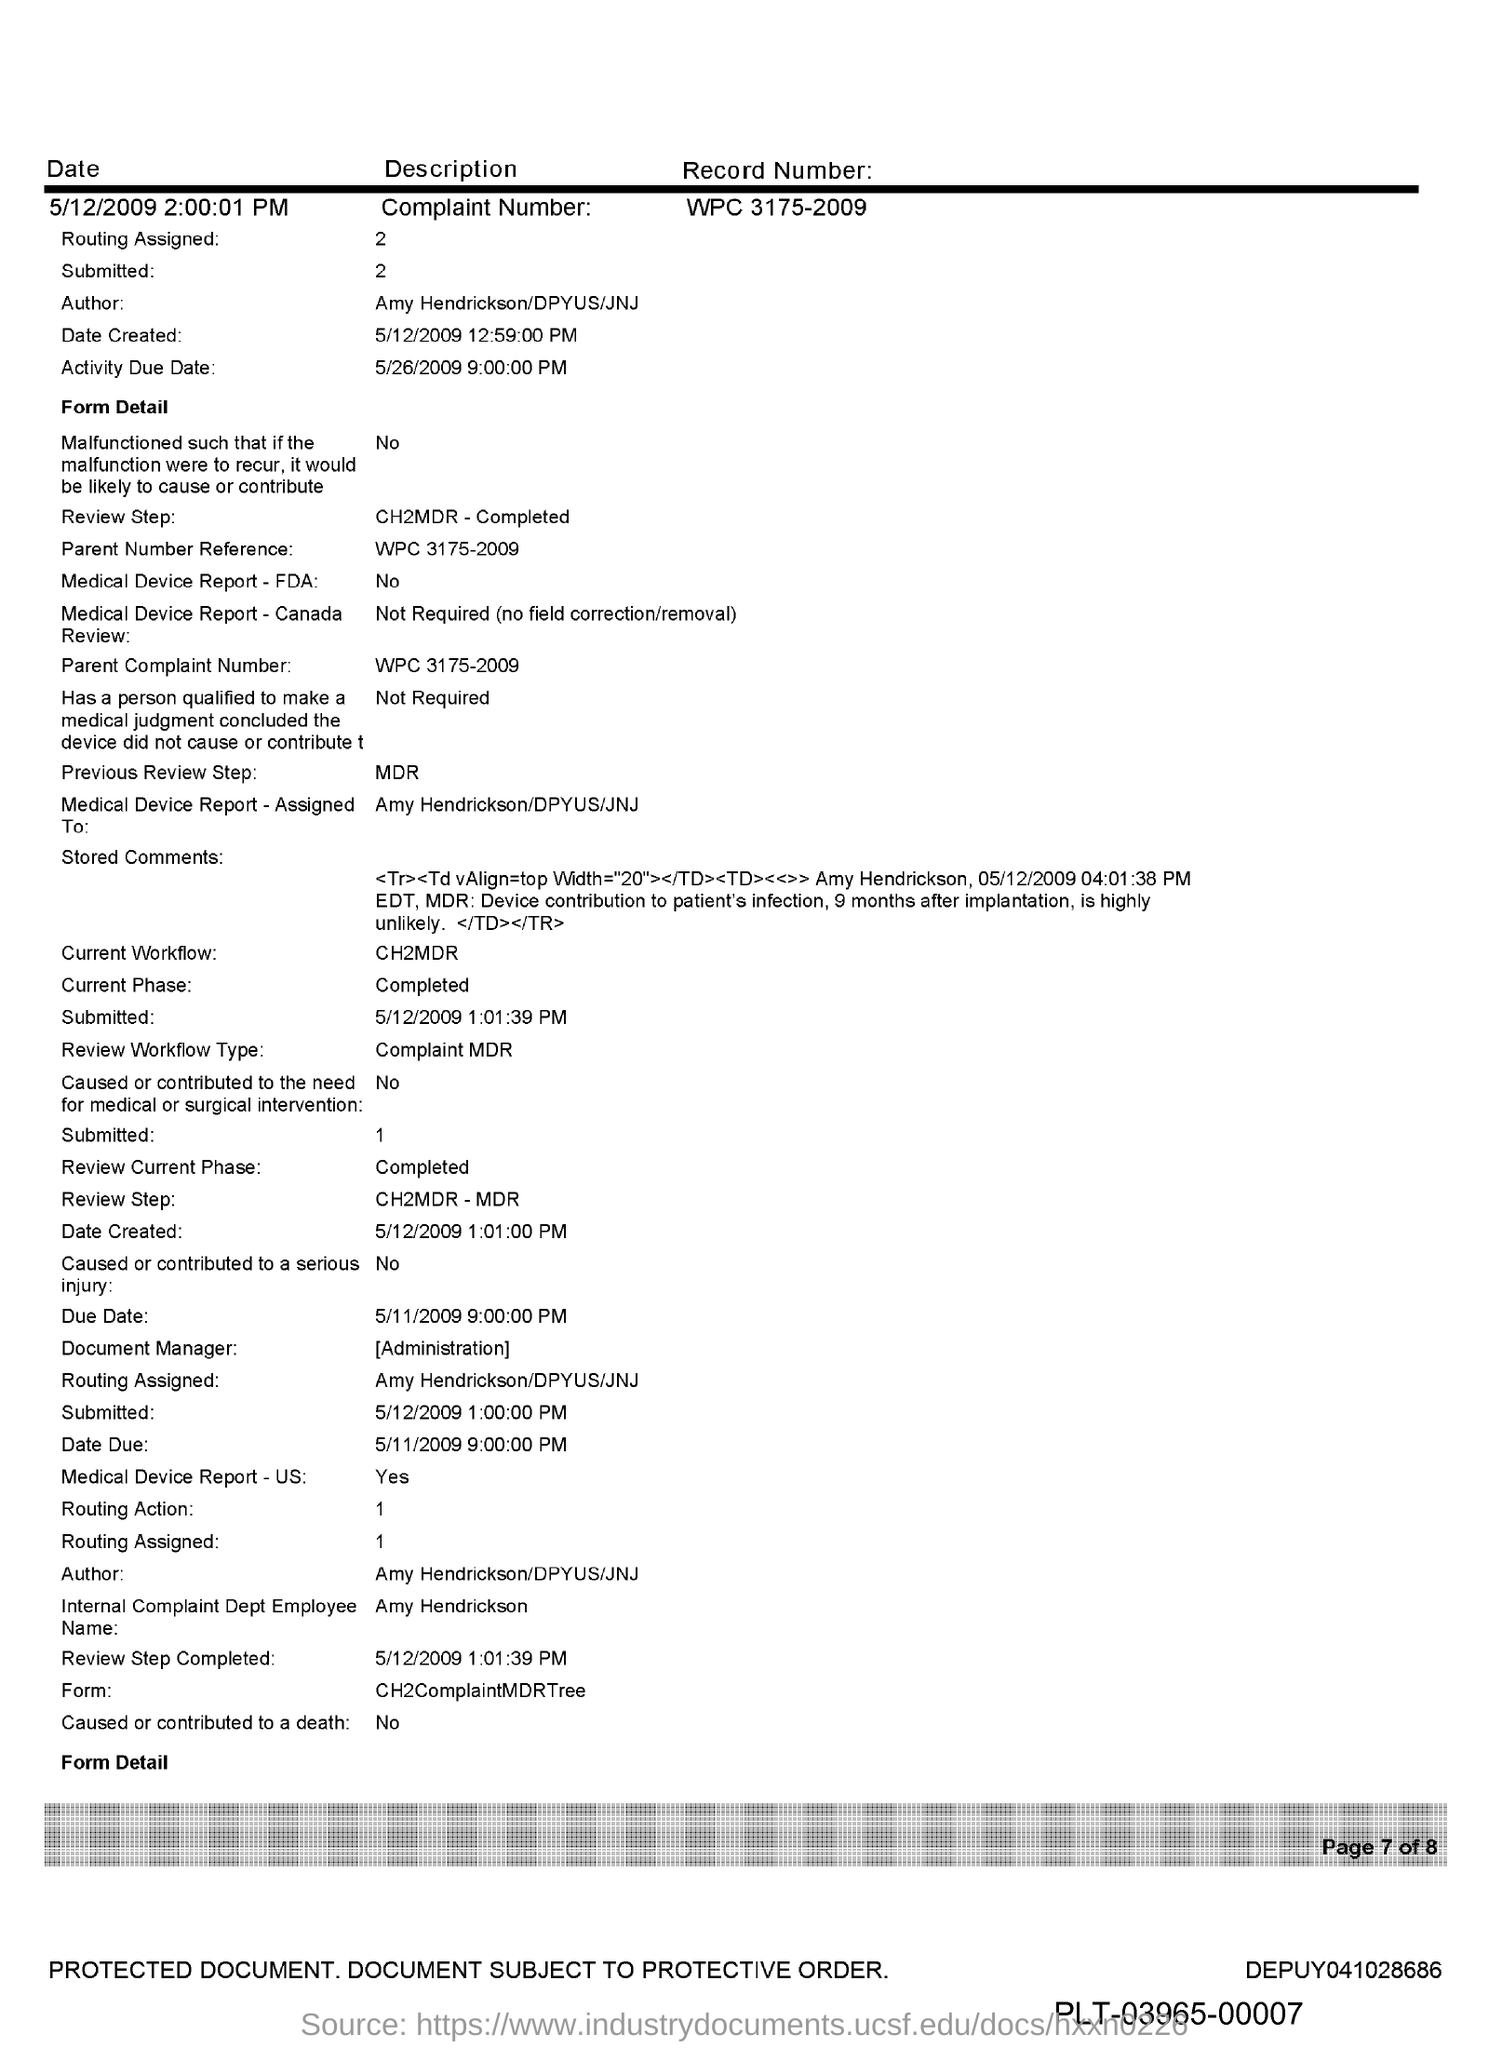What is the Parent Reference Number?
Your response must be concise. WPC 3175-2009. Who is the Author?
Your answer should be very brief. AMY HENDRICKSON/DPYUS/JNJ. 